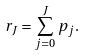Convert formula to latex. <formula><loc_0><loc_0><loc_500><loc_500>r _ { J } = \sum _ { j = 0 } ^ { J } p _ { j } .</formula> 